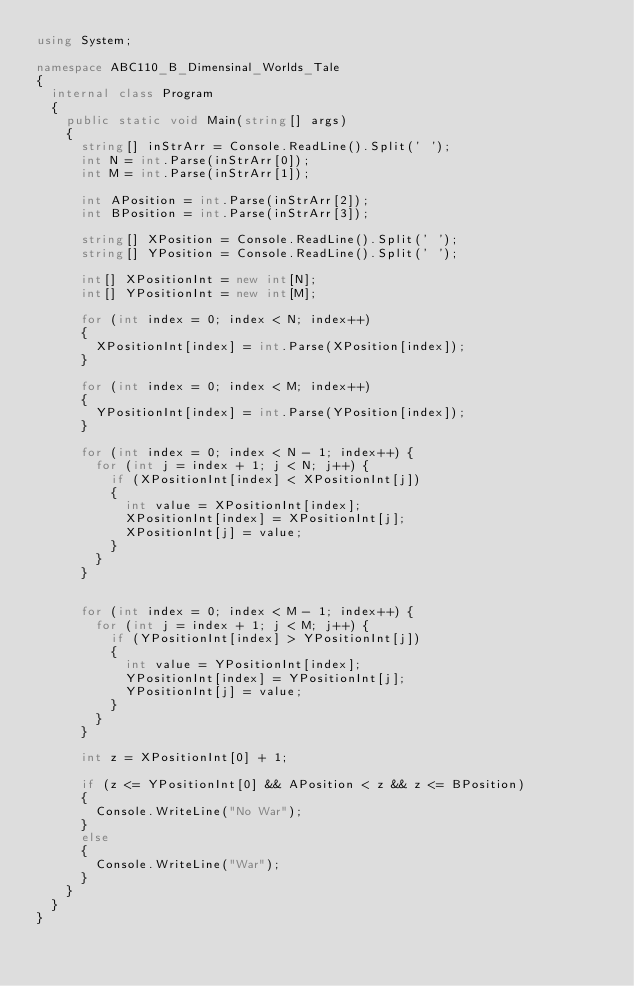Convert code to text. <code><loc_0><loc_0><loc_500><loc_500><_C#_>using System;

namespace ABC110_B_Dimensinal_Worlds_Tale
{
	internal class Program
	{
		public static void Main(string[] args)
		{
			string[] inStrArr = Console.ReadLine().Split(' ');
			int N = int.Parse(inStrArr[0]);
			int M = int.Parse(inStrArr[1]);

			int APosition = int.Parse(inStrArr[2]);
			int BPosition = int.Parse(inStrArr[3]);

			string[] XPosition = Console.ReadLine().Split(' ');
			string[] YPosition = Console.ReadLine().Split(' ');

			int[] XPositionInt = new int[N];
			int[] YPositionInt = new int[M];

			for (int index = 0; index < N; index++)
			{
				XPositionInt[index] = int.Parse(XPosition[index]);
			}
			
			for (int index = 0; index < M; index++)
			{
				YPositionInt[index] = int.Parse(YPosition[index]);
			}

			for (int index = 0; index < N - 1; index++) {
				for (int j = index + 1; j < N; j++) {
					if (XPositionInt[index] < XPositionInt[j])
					{
						int value = XPositionInt[index];
						XPositionInt[index] = XPositionInt[j];
						XPositionInt[j] = value;
					}
				}
			}
			
			
			for (int index = 0; index < M - 1; index++) {
				for (int j = index + 1; j < M; j++) {
					if (YPositionInt[index] > YPositionInt[j])
					{
						int value = YPositionInt[index];
						YPositionInt[index] = YPositionInt[j];
						YPositionInt[j] = value;
					}
				}
			}

			int z = XPositionInt[0] + 1;
			
			if (z <= YPositionInt[0] && APosition < z && z <= BPosition)
			{
				Console.WriteLine("No War");
			}
			else
			{
				Console.WriteLine("War");
			}
		}
	}
}</code> 